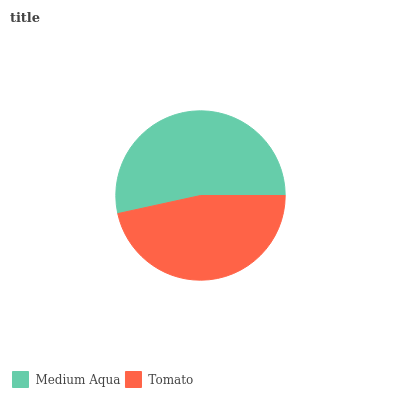Is Tomato the minimum?
Answer yes or no. Yes. Is Medium Aqua the maximum?
Answer yes or no. Yes. Is Tomato the maximum?
Answer yes or no. No. Is Medium Aqua greater than Tomato?
Answer yes or no. Yes. Is Tomato less than Medium Aqua?
Answer yes or no. Yes. Is Tomato greater than Medium Aqua?
Answer yes or no. No. Is Medium Aqua less than Tomato?
Answer yes or no. No. Is Medium Aqua the high median?
Answer yes or no. Yes. Is Tomato the low median?
Answer yes or no. Yes. Is Tomato the high median?
Answer yes or no. No. Is Medium Aqua the low median?
Answer yes or no. No. 